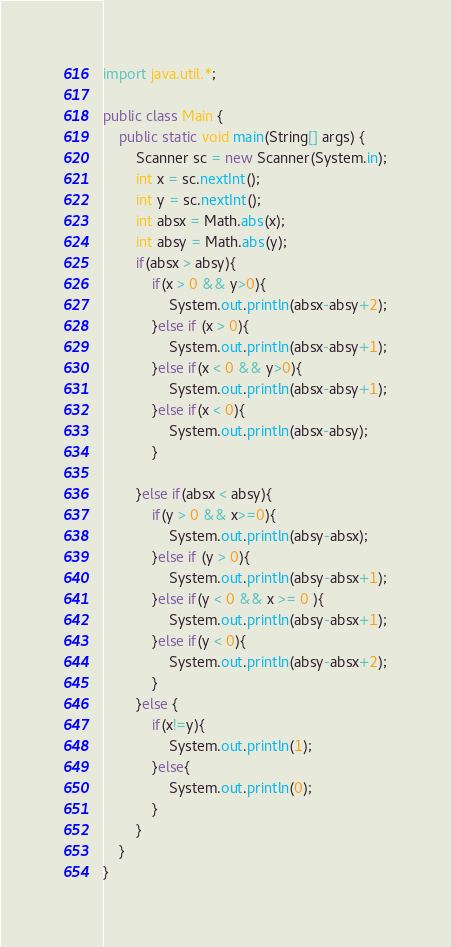Convert code to text. <code><loc_0><loc_0><loc_500><loc_500><_Java_>import java.util.*;

public class Main {
    public static void main(String[] args) {
        Scanner sc = new Scanner(System.in);
        int x = sc.nextInt();
        int y = sc.nextInt();
        int absx = Math.abs(x);
        int absy = Math.abs(y);
        if(absx > absy){
            if(x > 0 && y>0){
                System.out.println(absx-absy+2);
            }else if (x > 0){
                System.out.println(absx-absy+1);
            }else if(x < 0 && y>0){
                System.out.println(absx-absy+1);
            }else if(x < 0){
                System.out.println(absx-absy);
            }

        }else if(absx < absy){
            if(y > 0 && x>=0){
                System.out.println(absy-absx);
            }else if (y > 0){
                System.out.println(absy-absx+1);
            }else if(y < 0 && x >= 0 ){
                System.out.println(absy-absx+1);
            }else if(y < 0){
                System.out.println(absy-absx+2);
            }
        }else {
            if(x!=y){
                System.out.println(1);
            }else{
                System.out.println(0);
            }
        }
    }
}
</code> 